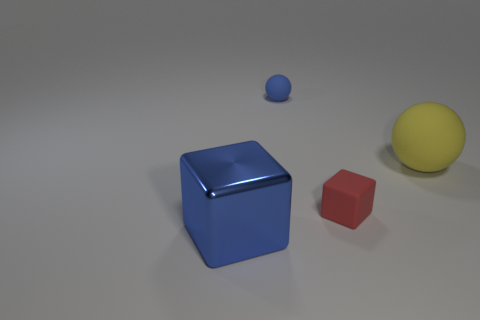There is a rubber object that is behind the large yellow matte ball; is its color the same as the big object to the left of the small blue thing?
Provide a succinct answer. Yes. There is a cube that is right of the big blue metallic block; what number of small blue rubber spheres are right of it?
Ensure brevity in your answer.  0. Is there a red block?
Your response must be concise. Yes. What number of other things are there of the same color as the metallic block?
Offer a very short reply. 1. Is the number of big cyan balls less than the number of large blue metal blocks?
Ensure brevity in your answer.  Yes. There is a big shiny object left of the thing that is right of the small red thing; what shape is it?
Offer a terse response. Cube. Are there any matte objects behind the big yellow ball?
Your answer should be very brief. Yes. What color is the other thing that is the same size as the red rubber thing?
Give a very brief answer. Blue. What number of small spheres are the same material as the big blue thing?
Give a very brief answer. 0. What number of other objects are the same size as the blue rubber sphere?
Keep it short and to the point. 1. 